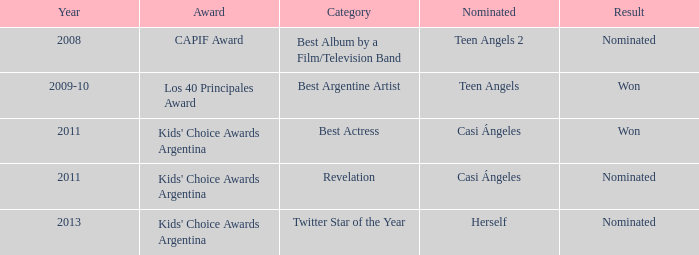In what category was Herself nominated? Twitter Star of the Year. 